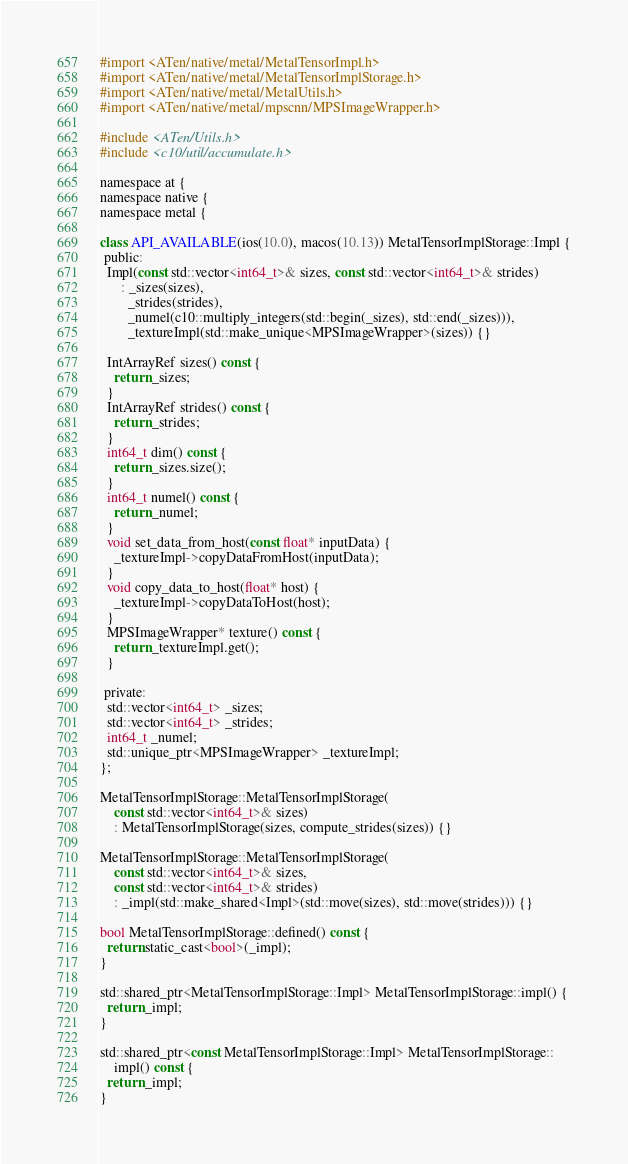<code> <loc_0><loc_0><loc_500><loc_500><_ObjectiveC_>#import <ATen/native/metal/MetalTensorImpl.h>
#import <ATen/native/metal/MetalTensorImplStorage.h>
#import <ATen/native/metal/MetalUtils.h>
#import <ATen/native/metal/mpscnn/MPSImageWrapper.h>

#include <ATen/Utils.h>
#include <c10/util/accumulate.h>

namespace at {
namespace native {
namespace metal {

class API_AVAILABLE(ios(10.0), macos(10.13)) MetalTensorImplStorage::Impl {
 public:
  Impl(const std::vector<int64_t>& sizes, const std::vector<int64_t>& strides)
      : _sizes(sizes),
        _strides(strides),
        _numel(c10::multiply_integers(std::begin(_sizes), std::end(_sizes))),
        _textureImpl(std::make_unique<MPSImageWrapper>(sizes)) {}

  IntArrayRef sizes() const {
    return _sizes;
  }
  IntArrayRef strides() const {
    return _strides;
  }
  int64_t dim() const {
    return _sizes.size();
  }
  int64_t numel() const {
    return _numel;
  }
  void set_data_from_host(const float* inputData) {
    _textureImpl->copyDataFromHost(inputData);
  }
  void copy_data_to_host(float* host) {
    _textureImpl->copyDataToHost(host);
  }
  MPSImageWrapper* texture() const {
    return _textureImpl.get();
  }

 private:
  std::vector<int64_t> _sizes;
  std::vector<int64_t> _strides;
  int64_t _numel;
  std::unique_ptr<MPSImageWrapper> _textureImpl;
};

MetalTensorImplStorage::MetalTensorImplStorage(
    const std::vector<int64_t>& sizes)
    : MetalTensorImplStorage(sizes, compute_strides(sizes)) {}

MetalTensorImplStorage::MetalTensorImplStorage(
    const std::vector<int64_t>& sizes,
    const std::vector<int64_t>& strides)
    : _impl(std::make_shared<Impl>(std::move(sizes), std::move(strides))) {}

bool MetalTensorImplStorage::defined() const {
  return static_cast<bool>(_impl);
}

std::shared_ptr<MetalTensorImplStorage::Impl> MetalTensorImplStorage::impl() {
  return _impl;
}

std::shared_ptr<const MetalTensorImplStorage::Impl> MetalTensorImplStorage::
    impl() const {
  return _impl;
}
</code> 